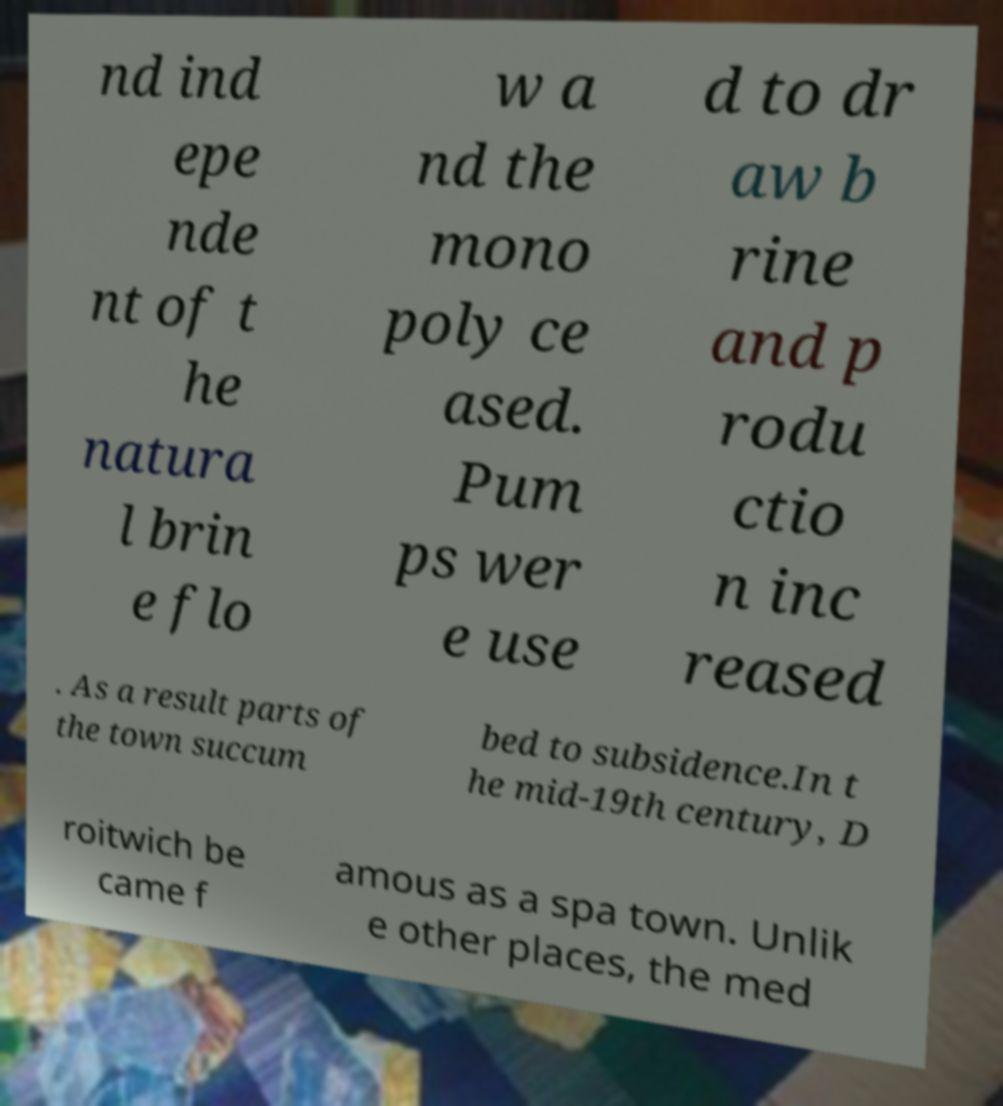There's text embedded in this image that I need extracted. Can you transcribe it verbatim? nd ind epe nde nt of t he natura l brin e flo w a nd the mono poly ce ased. Pum ps wer e use d to dr aw b rine and p rodu ctio n inc reased . As a result parts of the town succum bed to subsidence.In t he mid-19th century, D roitwich be came f amous as a spa town. Unlik e other places, the med 